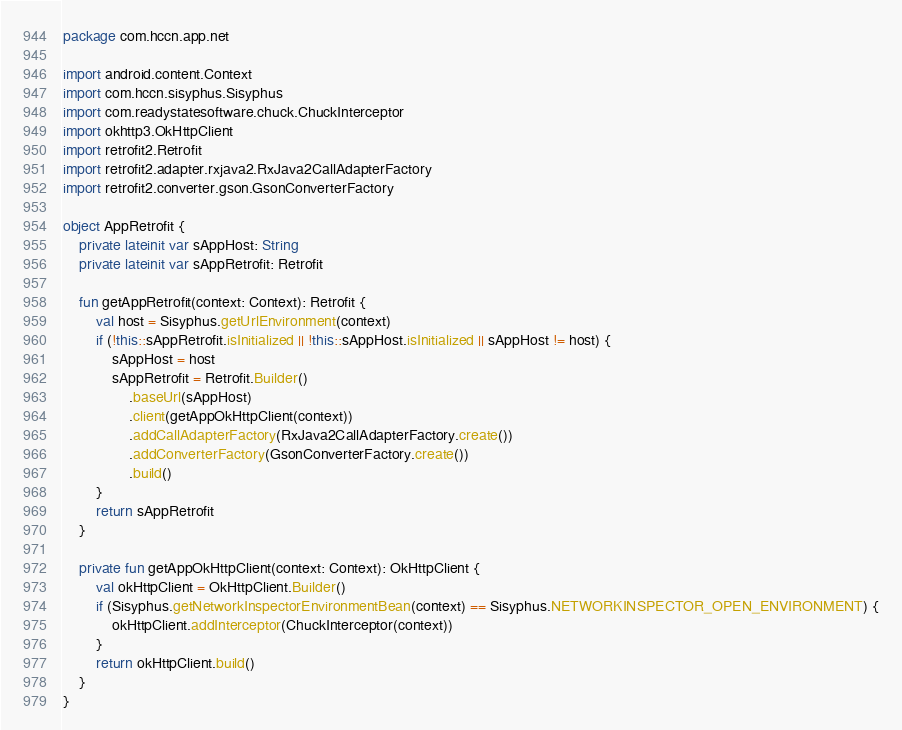Convert code to text. <code><loc_0><loc_0><loc_500><loc_500><_Kotlin_>package com.hccn.app.net

import android.content.Context
import com.hccn.sisyphus.Sisyphus
import com.readystatesoftware.chuck.ChuckInterceptor
import okhttp3.OkHttpClient
import retrofit2.Retrofit
import retrofit2.adapter.rxjava2.RxJava2CallAdapterFactory
import retrofit2.converter.gson.GsonConverterFactory

object AppRetrofit {
    private lateinit var sAppHost: String
    private lateinit var sAppRetrofit: Retrofit

    fun getAppRetrofit(context: Context): Retrofit {
        val host = Sisyphus.getUrlEnvironment(context)
        if (!this::sAppRetrofit.isInitialized || !this::sAppHost.isInitialized || sAppHost != host) {
            sAppHost = host
            sAppRetrofit = Retrofit.Builder()
                .baseUrl(sAppHost)
                .client(getAppOkHttpClient(context))
                .addCallAdapterFactory(RxJava2CallAdapterFactory.create())
                .addConverterFactory(GsonConverterFactory.create())
                .build()
        }
        return sAppRetrofit
    }

    private fun getAppOkHttpClient(context: Context): OkHttpClient {
        val okHttpClient = OkHttpClient.Builder()
        if (Sisyphus.getNetworkInspectorEnvironmentBean(context) == Sisyphus.NETWORKINSPECTOR_OPEN_ENVIRONMENT) {
            okHttpClient.addInterceptor(ChuckInterceptor(context))
        }
        return okHttpClient.build()
    }
}</code> 